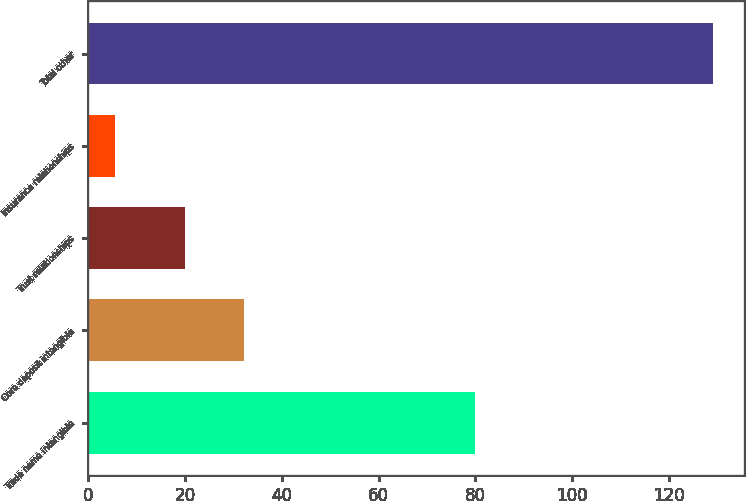Convert chart. <chart><loc_0><loc_0><loc_500><loc_500><bar_chart><fcel>Trade name intangible<fcel>Core deposit intangible<fcel>Trust relationships<fcel>Insurance relationships<fcel>Total other<nl><fcel>79.9<fcel>32.26<fcel>19.9<fcel>5.5<fcel>129.1<nl></chart> 